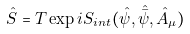Convert formula to latex. <formula><loc_0><loc_0><loc_500><loc_500>\hat { S } = T \exp { i S _ { i n t } ( \hat { \psi } , \hat { \bar { \psi } } , \hat { A } _ { \mu } ) }</formula> 